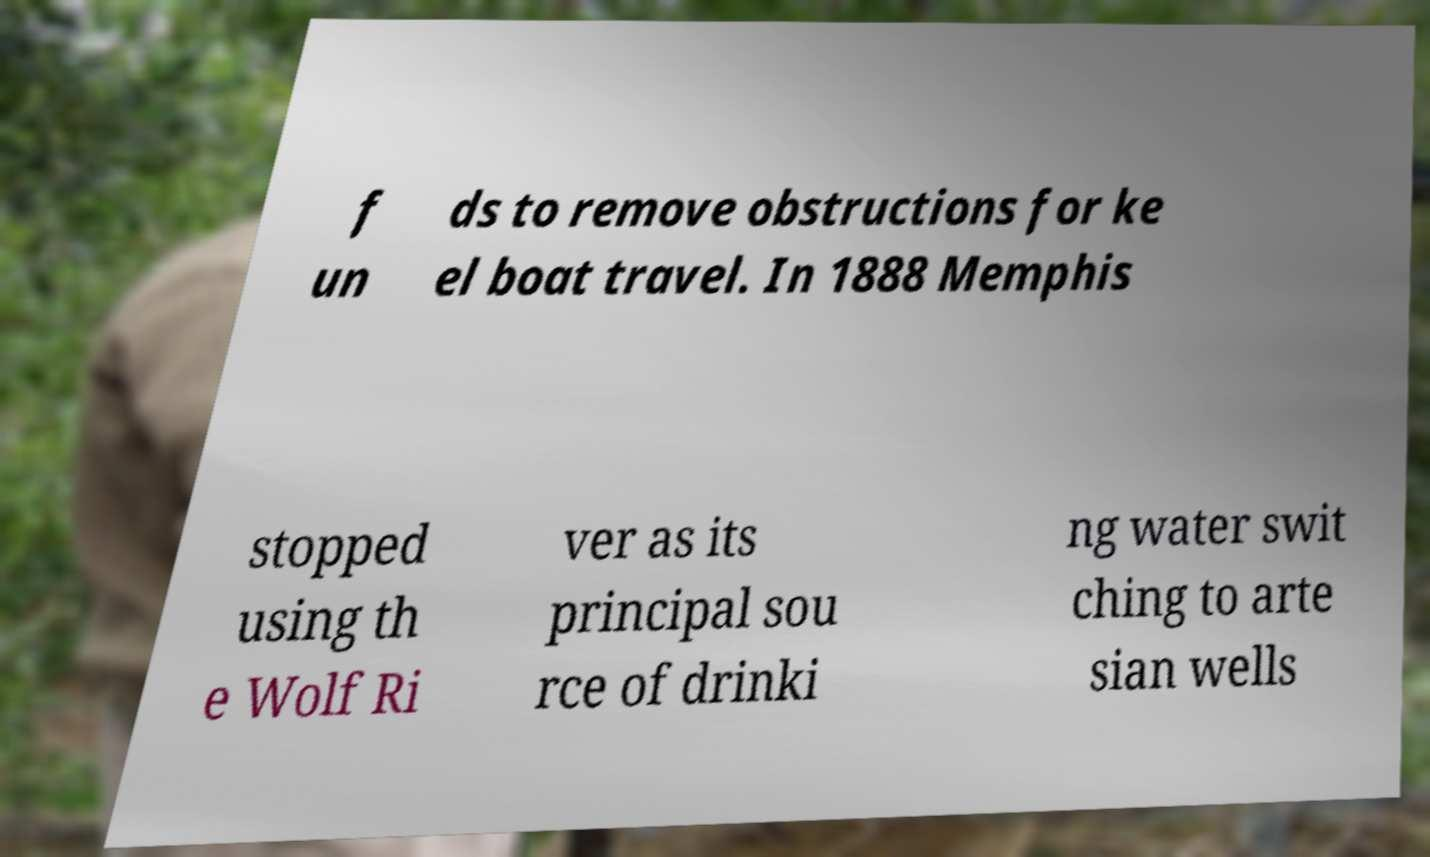What messages or text are displayed in this image? I need them in a readable, typed format. f un ds to remove obstructions for ke el boat travel. In 1888 Memphis stopped using th e Wolf Ri ver as its principal sou rce of drinki ng water swit ching to arte sian wells 